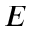<formula> <loc_0><loc_0><loc_500><loc_500>E</formula> 